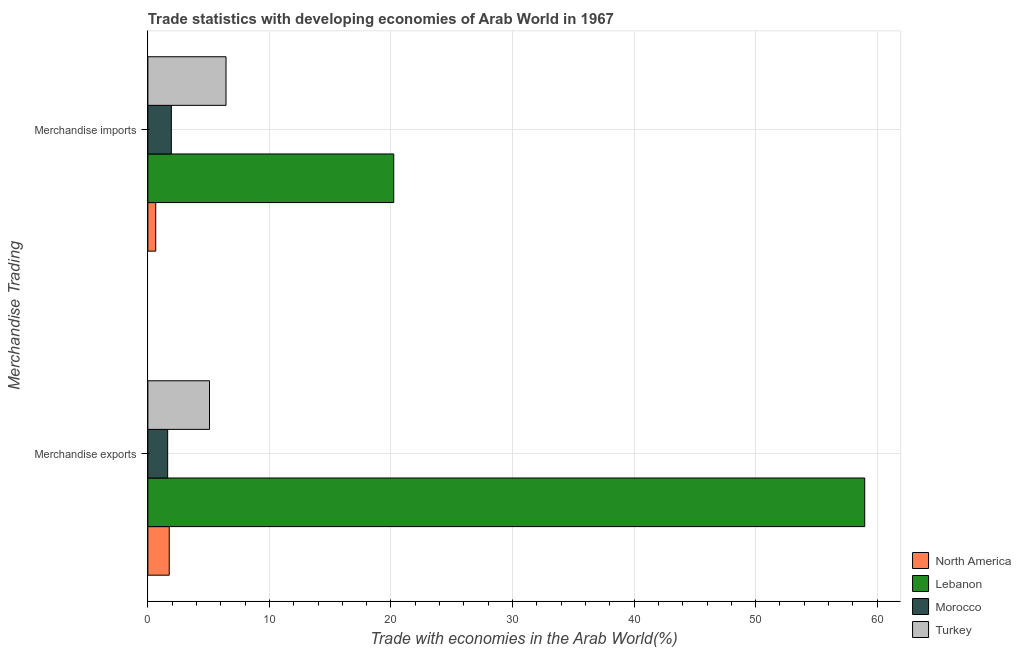Are the number of bars per tick equal to the number of legend labels?
Provide a short and direct response. Yes. How many bars are there on the 2nd tick from the top?
Provide a short and direct response. 4. What is the merchandise imports in Morocco?
Ensure brevity in your answer.  1.93. Across all countries, what is the maximum merchandise imports?
Keep it short and to the point. 20.23. Across all countries, what is the minimum merchandise exports?
Provide a short and direct response. 1.63. In which country was the merchandise exports maximum?
Provide a short and direct response. Lebanon. In which country was the merchandise exports minimum?
Make the answer very short. Morocco. What is the total merchandise exports in the graph?
Keep it short and to the point. 67.43. What is the difference between the merchandise exports in North America and that in Turkey?
Provide a succinct answer. -3.31. What is the difference between the merchandise exports in Turkey and the merchandise imports in Lebanon?
Your answer should be very brief. -15.16. What is the average merchandise exports per country?
Ensure brevity in your answer.  16.86. What is the difference between the merchandise imports and merchandise exports in Turkey?
Provide a succinct answer. 1.36. In how many countries, is the merchandise exports greater than 24 %?
Your response must be concise. 1. What is the ratio of the merchandise exports in Turkey to that in North America?
Ensure brevity in your answer.  2.89. What does the 3rd bar from the top in Merchandise imports represents?
Offer a terse response. Lebanon. What does the 3rd bar from the bottom in Merchandise exports represents?
Your answer should be very brief. Morocco. How many bars are there?
Your answer should be very brief. 8. How many countries are there in the graph?
Give a very brief answer. 4. What is the difference between two consecutive major ticks on the X-axis?
Your answer should be very brief. 10. Are the values on the major ticks of X-axis written in scientific E-notation?
Offer a very short reply. No. Where does the legend appear in the graph?
Keep it short and to the point. Bottom right. How many legend labels are there?
Your response must be concise. 4. What is the title of the graph?
Give a very brief answer. Trade statistics with developing economies of Arab World in 1967. What is the label or title of the X-axis?
Your response must be concise. Trade with economies in the Arab World(%). What is the label or title of the Y-axis?
Give a very brief answer. Merchandise Trading. What is the Trade with economies in the Arab World(%) of North America in Merchandise exports?
Your answer should be very brief. 1.76. What is the Trade with economies in the Arab World(%) of Lebanon in Merchandise exports?
Ensure brevity in your answer.  58.97. What is the Trade with economies in the Arab World(%) of Morocco in Merchandise exports?
Provide a succinct answer. 1.63. What is the Trade with economies in the Arab World(%) of Turkey in Merchandise exports?
Your response must be concise. 5.07. What is the Trade with economies in the Arab World(%) of North America in Merchandise imports?
Give a very brief answer. 0.65. What is the Trade with economies in the Arab World(%) in Lebanon in Merchandise imports?
Your response must be concise. 20.23. What is the Trade with economies in the Arab World(%) of Morocco in Merchandise imports?
Provide a succinct answer. 1.93. What is the Trade with economies in the Arab World(%) of Turkey in Merchandise imports?
Provide a succinct answer. 6.43. Across all Merchandise Trading, what is the maximum Trade with economies in the Arab World(%) in North America?
Your response must be concise. 1.76. Across all Merchandise Trading, what is the maximum Trade with economies in the Arab World(%) of Lebanon?
Your answer should be compact. 58.97. Across all Merchandise Trading, what is the maximum Trade with economies in the Arab World(%) in Morocco?
Offer a terse response. 1.93. Across all Merchandise Trading, what is the maximum Trade with economies in the Arab World(%) of Turkey?
Your response must be concise. 6.43. Across all Merchandise Trading, what is the minimum Trade with economies in the Arab World(%) of North America?
Provide a succinct answer. 0.65. Across all Merchandise Trading, what is the minimum Trade with economies in the Arab World(%) of Lebanon?
Make the answer very short. 20.23. Across all Merchandise Trading, what is the minimum Trade with economies in the Arab World(%) in Morocco?
Provide a short and direct response. 1.63. Across all Merchandise Trading, what is the minimum Trade with economies in the Arab World(%) in Turkey?
Offer a terse response. 5.07. What is the total Trade with economies in the Arab World(%) in North America in the graph?
Your answer should be compact. 2.4. What is the total Trade with economies in the Arab World(%) of Lebanon in the graph?
Your answer should be very brief. 79.2. What is the total Trade with economies in the Arab World(%) in Morocco in the graph?
Your response must be concise. 3.56. What is the total Trade with economies in the Arab World(%) of Turkey in the graph?
Give a very brief answer. 11.5. What is the difference between the Trade with economies in the Arab World(%) in North America in Merchandise exports and that in Merchandise imports?
Give a very brief answer. 1.11. What is the difference between the Trade with economies in the Arab World(%) of Lebanon in Merchandise exports and that in Merchandise imports?
Your answer should be compact. 38.74. What is the difference between the Trade with economies in the Arab World(%) of Morocco in Merchandise exports and that in Merchandise imports?
Offer a very short reply. -0.3. What is the difference between the Trade with economies in the Arab World(%) in Turkey in Merchandise exports and that in Merchandise imports?
Your answer should be very brief. -1.36. What is the difference between the Trade with economies in the Arab World(%) of North America in Merchandise exports and the Trade with economies in the Arab World(%) of Lebanon in Merchandise imports?
Keep it short and to the point. -18.47. What is the difference between the Trade with economies in the Arab World(%) of North America in Merchandise exports and the Trade with economies in the Arab World(%) of Morocco in Merchandise imports?
Ensure brevity in your answer.  -0.17. What is the difference between the Trade with economies in the Arab World(%) in North America in Merchandise exports and the Trade with economies in the Arab World(%) in Turkey in Merchandise imports?
Your response must be concise. -4.67. What is the difference between the Trade with economies in the Arab World(%) of Lebanon in Merchandise exports and the Trade with economies in the Arab World(%) of Morocco in Merchandise imports?
Give a very brief answer. 57.04. What is the difference between the Trade with economies in the Arab World(%) in Lebanon in Merchandise exports and the Trade with economies in the Arab World(%) in Turkey in Merchandise imports?
Keep it short and to the point. 52.54. What is the difference between the Trade with economies in the Arab World(%) in Morocco in Merchandise exports and the Trade with economies in the Arab World(%) in Turkey in Merchandise imports?
Provide a short and direct response. -4.8. What is the average Trade with economies in the Arab World(%) of North America per Merchandise Trading?
Make the answer very short. 1.2. What is the average Trade with economies in the Arab World(%) in Lebanon per Merchandise Trading?
Your response must be concise. 39.6. What is the average Trade with economies in the Arab World(%) in Morocco per Merchandise Trading?
Offer a terse response. 1.78. What is the average Trade with economies in the Arab World(%) in Turkey per Merchandise Trading?
Make the answer very short. 5.75. What is the difference between the Trade with economies in the Arab World(%) of North America and Trade with economies in the Arab World(%) of Lebanon in Merchandise exports?
Provide a short and direct response. -57.22. What is the difference between the Trade with economies in the Arab World(%) of North America and Trade with economies in the Arab World(%) of Morocco in Merchandise exports?
Your answer should be compact. 0.13. What is the difference between the Trade with economies in the Arab World(%) of North America and Trade with economies in the Arab World(%) of Turkey in Merchandise exports?
Keep it short and to the point. -3.31. What is the difference between the Trade with economies in the Arab World(%) of Lebanon and Trade with economies in the Arab World(%) of Morocco in Merchandise exports?
Offer a very short reply. 57.35. What is the difference between the Trade with economies in the Arab World(%) of Lebanon and Trade with economies in the Arab World(%) of Turkey in Merchandise exports?
Your answer should be very brief. 53.9. What is the difference between the Trade with economies in the Arab World(%) in Morocco and Trade with economies in the Arab World(%) in Turkey in Merchandise exports?
Give a very brief answer. -3.44. What is the difference between the Trade with economies in the Arab World(%) in North America and Trade with economies in the Arab World(%) in Lebanon in Merchandise imports?
Keep it short and to the point. -19.58. What is the difference between the Trade with economies in the Arab World(%) in North America and Trade with economies in the Arab World(%) in Morocco in Merchandise imports?
Offer a terse response. -1.28. What is the difference between the Trade with economies in the Arab World(%) in North America and Trade with economies in the Arab World(%) in Turkey in Merchandise imports?
Provide a succinct answer. -5.78. What is the difference between the Trade with economies in the Arab World(%) in Lebanon and Trade with economies in the Arab World(%) in Morocco in Merchandise imports?
Provide a short and direct response. 18.3. What is the difference between the Trade with economies in the Arab World(%) of Lebanon and Trade with economies in the Arab World(%) of Turkey in Merchandise imports?
Offer a very short reply. 13.8. What is the difference between the Trade with economies in the Arab World(%) in Morocco and Trade with economies in the Arab World(%) in Turkey in Merchandise imports?
Your response must be concise. -4.5. What is the ratio of the Trade with economies in the Arab World(%) in North America in Merchandise exports to that in Merchandise imports?
Your answer should be very brief. 2.72. What is the ratio of the Trade with economies in the Arab World(%) in Lebanon in Merchandise exports to that in Merchandise imports?
Provide a short and direct response. 2.92. What is the ratio of the Trade with economies in the Arab World(%) in Morocco in Merchandise exports to that in Merchandise imports?
Offer a terse response. 0.84. What is the ratio of the Trade with economies in the Arab World(%) of Turkey in Merchandise exports to that in Merchandise imports?
Provide a short and direct response. 0.79. What is the difference between the highest and the second highest Trade with economies in the Arab World(%) of North America?
Your answer should be compact. 1.11. What is the difference between the highest and the second highest Trade with economies in the Arab World(%) in Lebanon?
Your answer should be very brief. 38.74. What is the difference between the highest and the second highest Trade with economies in the Arab World(%) of Morocco?
Keep it short and to the point. 0.3. What is the difference between the highest and the second highest Trade with economies in the Arab World(%) of Turkey?
Give a very brief answer. 1.36. What is the difference between the highest and the lowest Trade with economies in the Arab World(%) in North America?
Your response must be concise. 1.11. What is the difference between the highest and the lowest Trade with economies in the Arab World(%) in Lebanon?
Your answer should be compact. 38.74. What is the difference between the highest and the lowest Trade with economies in the Arab World(%) of Morocco?
Your answer should be very brief. 0.3. What is the difference between the highest and the lowest Trade with economies in the Arab World(%) in Turkey?
Your response must be concise. 1.36. 